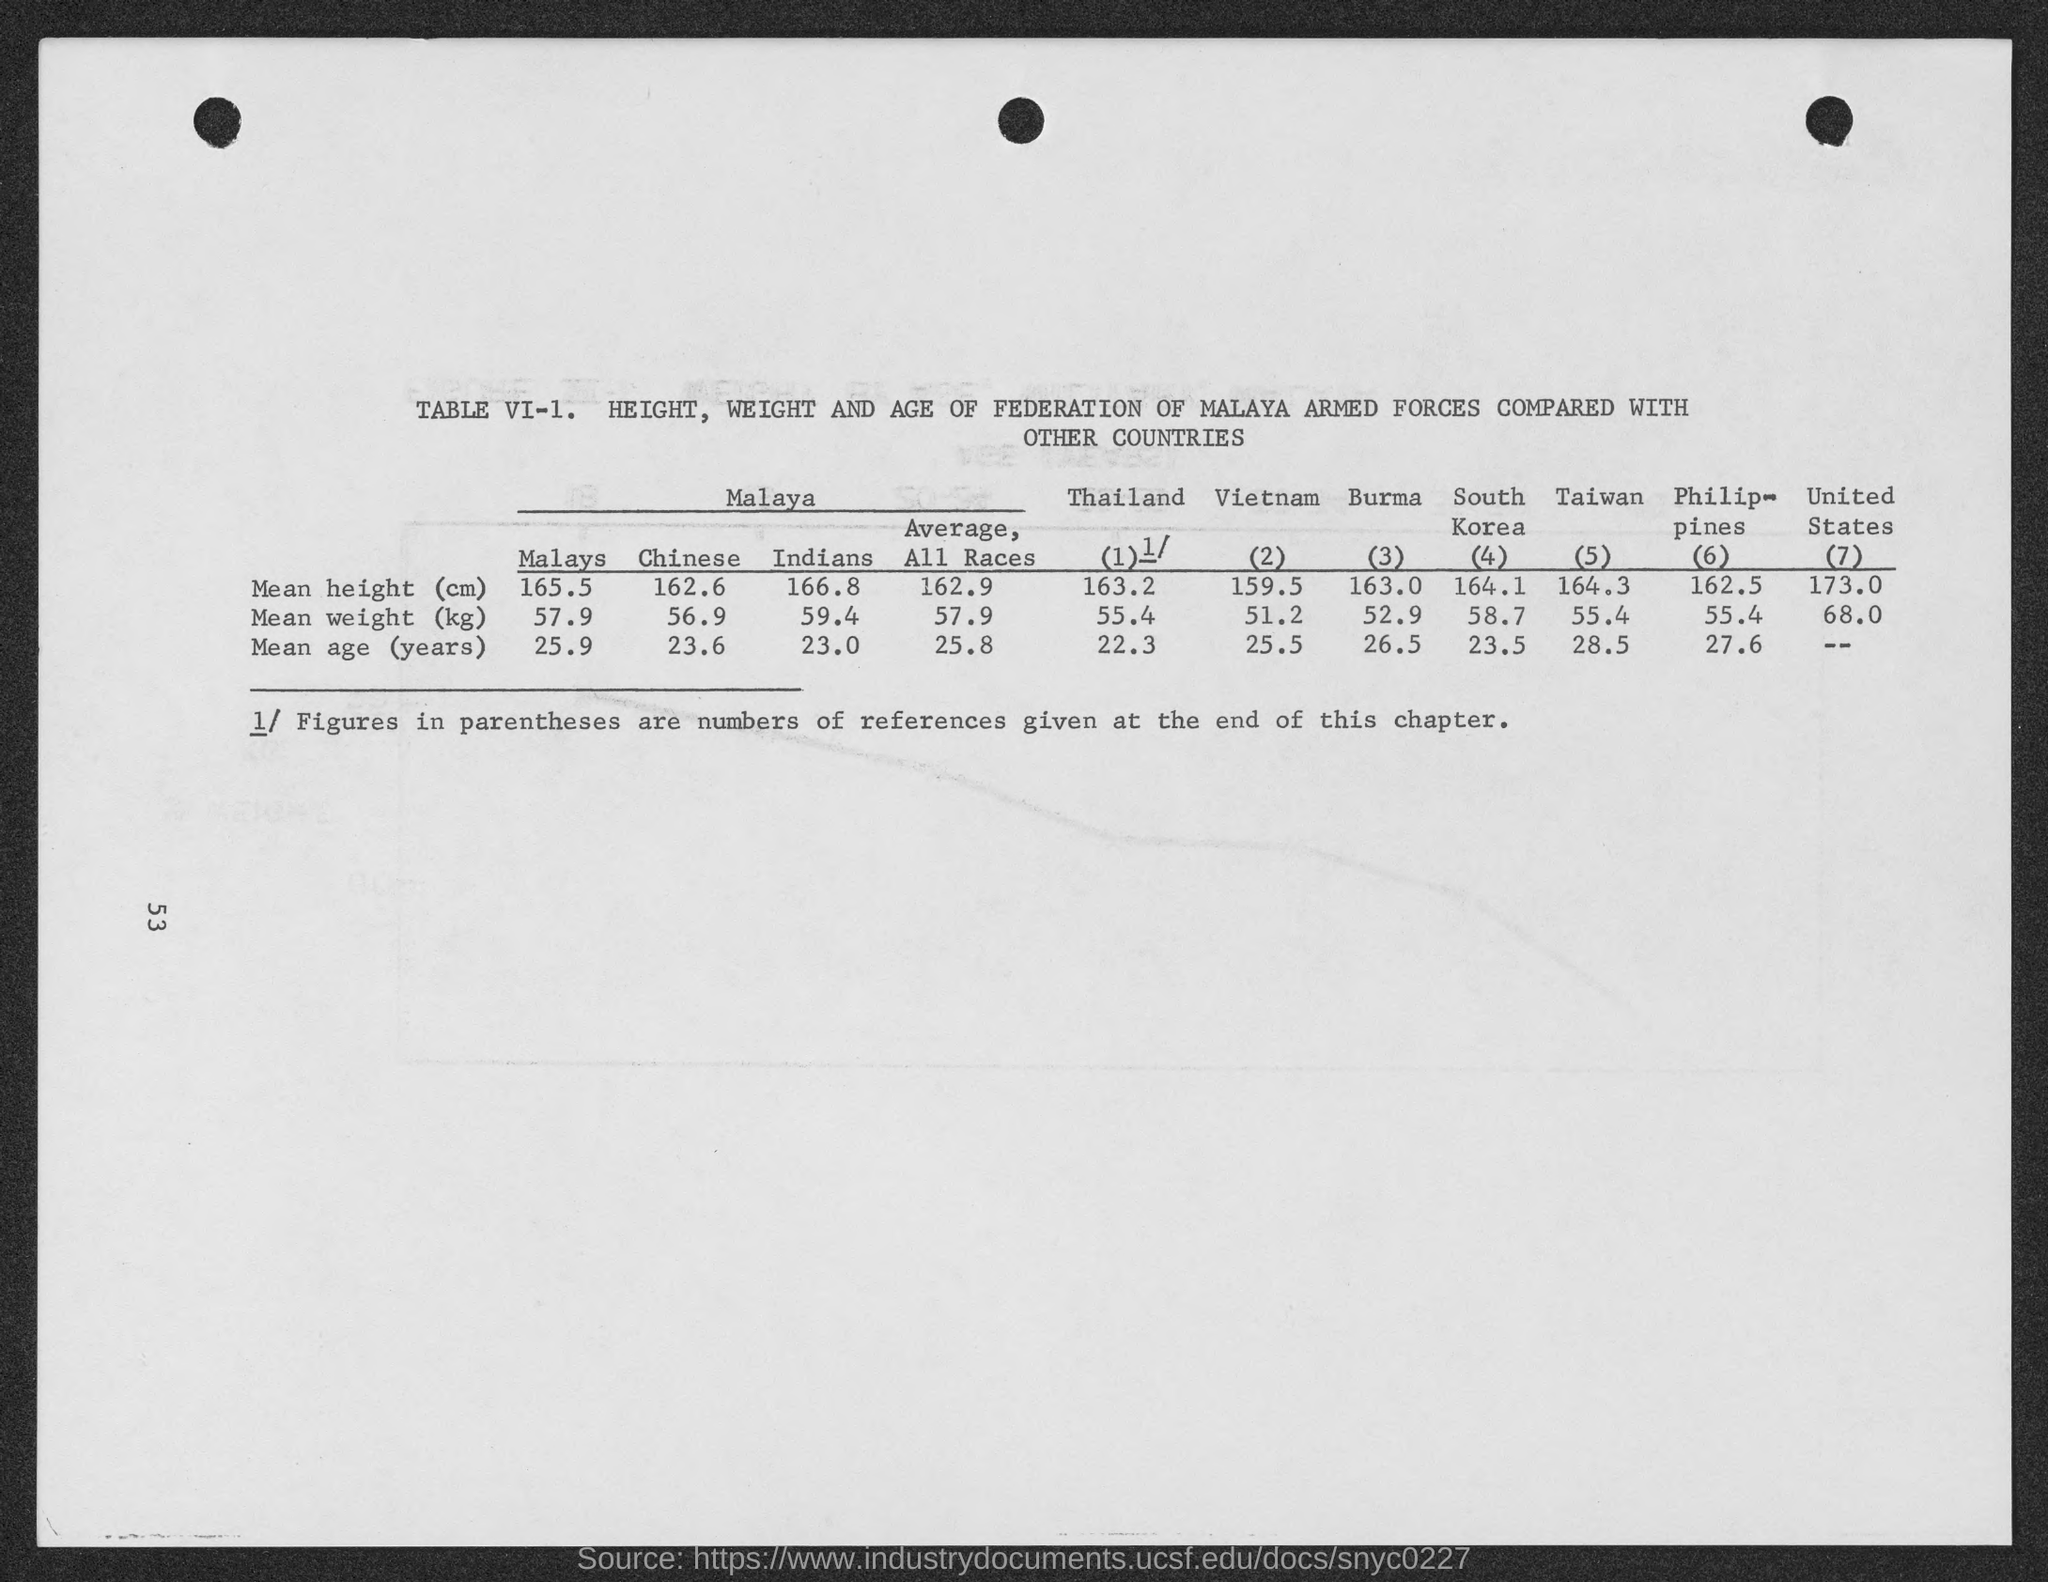What is the mean height (cm) in malays?
Give a very brief answer. 165.5. What is the mean height (cm) in chinese ?
Your answer should be very brief. 162.6. What is the mean height (cm) in indians?
Your answer should be compact. 166.8. What is the mean height (cm) in average, all races?
Provide a succinct answer. 162.9. What is the mean height (cm) in thailand ?
Offer a very short reply. 163.2. What is the mean height (cm) in vietnam ?
Keep it short and to the point. 159.5. What is the mean height (cm) in burma ?
Your response must be concise. 163.0. What is the mean height (cm) in south korea ?
Provide a succinct answer. 164.1. What is the mean height (cm) in taiwan ?
Give a very brief answer. 164.3. 